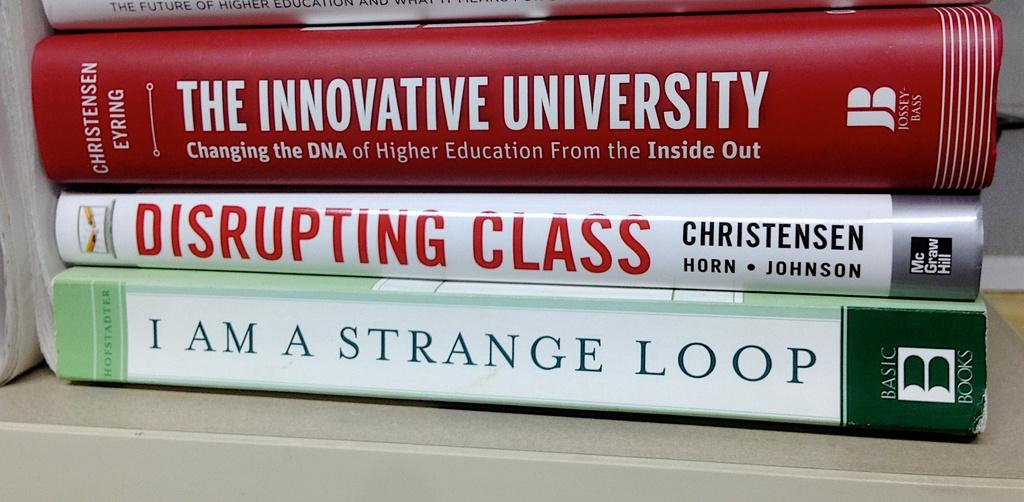<image>
Give a short and clear explanation of the subsequent image. The books The Innovative University, Disrupting Class, and I Am A Strange Loop stacked on top of each other. 